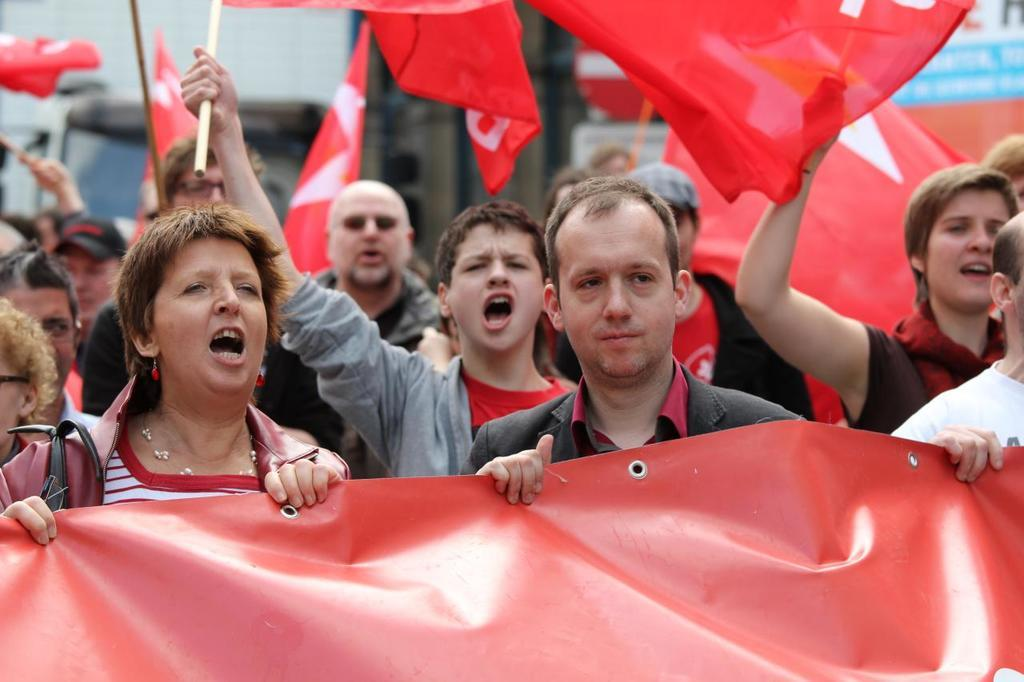What is happening in the image? There are people on the road in the image. Can you describe the people in the image? There are both men and women in the image. What are some of the people holding in their hands? Some people are holding red color flags in their hands. How would you describe the background of the image? The background of the image is blurred. Where is the fireman sitting on his throne in the image? There is no fireman or throne present in the image. 